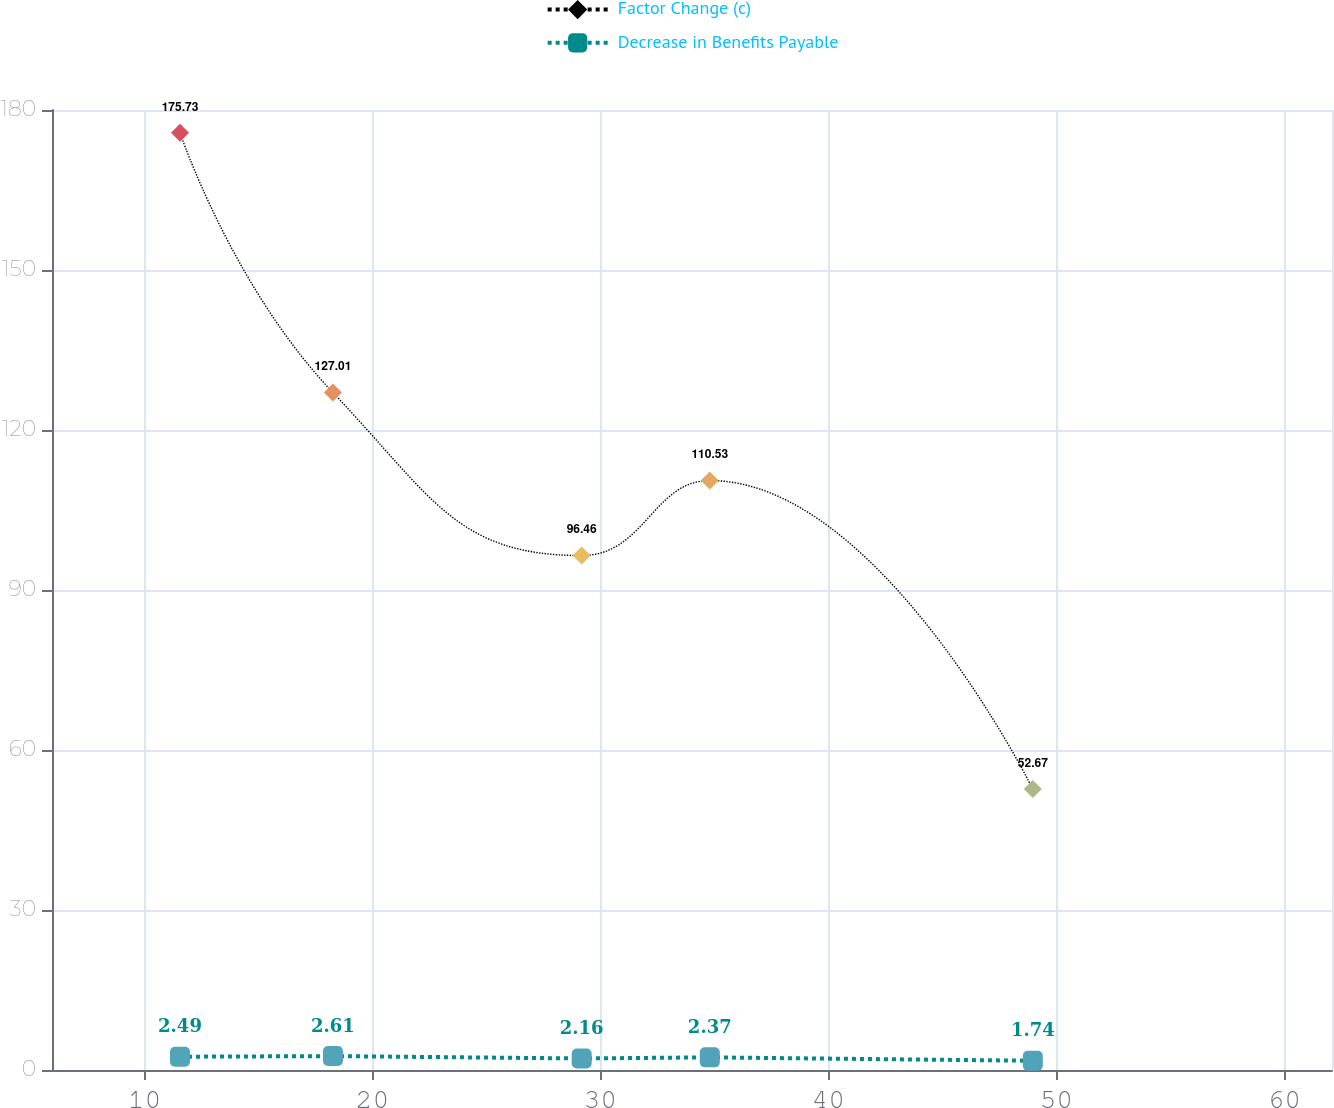Convert chart. <chart><loc_0><loc_0><loc_500><loc_500><line_chart><ecel><fcel>Factor Change (c)<fcel>Decrease in Benefits Payable<nl><fcel>11.56<fcel>175.73<fcel>2.49<nl><fcel>18.27<fcel>127.01<fcel>2.61<nl><fcel>29.18<fcel>96.46<fcel>2.16<nl><fcel>34.8<fcel>110.53<fcel>2.37<nl><fcel>48.97<fcel>52.67<fcel>1.74<nl><fcel>67.71<fcel>35<fcel>1.26<nl></chart> 